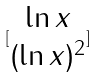<formula> <loc_0><loc_0><loc_500><loc_500>[ \begin{matrix} \ln x \\ ( \ln x ) ^ { 2 } \end{matrix} ]</formula> 